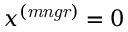Convert formula to latex. <formula><loc_0><loc_0><loc_500><loc_500>x ^ { ( m n g r ) } = 0</formula> 